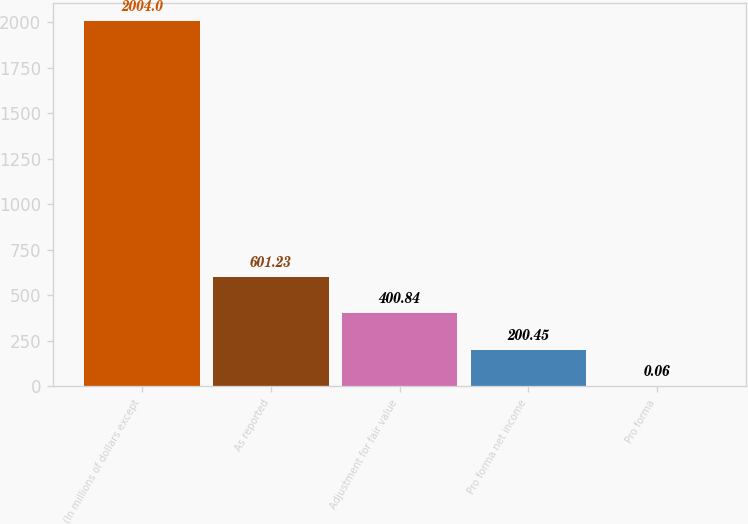<chart> <loc_0><loc_0><loc_500><loc_500><bar_chart><fcel>(In millions of dollars except<fcel>As reported<fcel>Adjustment for fair value<fcel>Pro forma net income<fcel>Pro forma<nl><fcel>2004<fcel>601.23<fcel>400.84<fcel>200.45<fcel>0.06<nl></chart> 